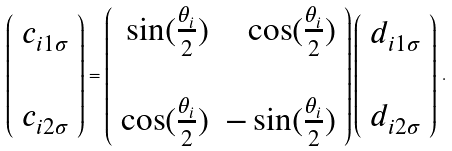Convert formula to latex. <formula><loc_0><loc_0><loc_500><loc_500>\left ( \begin{array} { c } c _ { i 1 \sigma } \\ \\ c _ { i 2 \sigma } \end{array} \right ) = \left ( \begin{array} { r r } \sin ( \frac { \theta _ { i } } { 2 } ) & \cos ( \frac { \theta _ { i } } { 2 } ) \\ \\ \cos ( \frac { \theta _ { i } } { 2 } ) & - \sin ( \frac { \theta _ { i } } { 2 } ) \end{array} \right ) \left ( \begin{array} { c } d _ { i 1 \sigma } \\ \\ d _ { i 2 \sigma } \end{array} \right ) \, .</formula> 